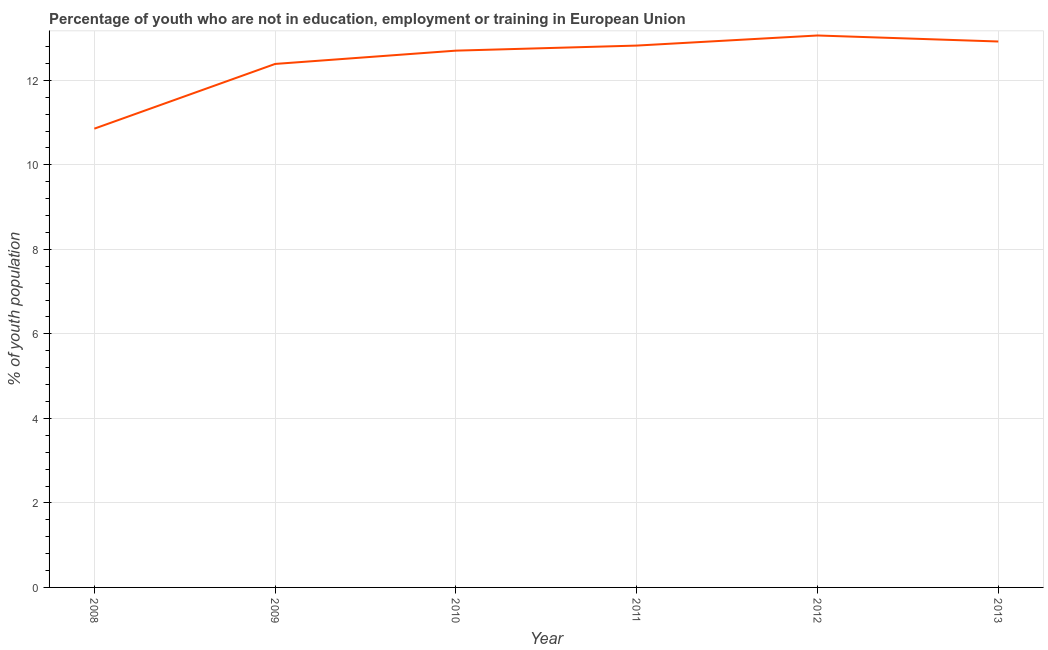What is the unemployed youth population in 2008?
Your response must be concise. 10.86. Across all years, what is the maximum unemployed youth population?
Your response must be concise. 13.06. Across all years, what is the minimum unemployed youth population?
Ensure brevity in your answer.  10.86. In which year was the unemployed youth population minimum?
Keep it short and to the point. 2008. What is the sum of the unemployed youth population?
Your answer should be very brief. 74.74. What is the difference between the unemployed youth population in 2011 and 2012?
Keep it short and to the point. -0.24. What is the average unemployed youth population per year?
Offer a terse response. 12.46. What is the median unemployed youth population?
Make the answer very short. 12.76. What is the ratio of the unemployed youth population in 2008 to that in 2011?
Your response must be concise. 0.85. Is the unemployed youth population in 2008 less than that in 2010?
Give a very brief answer. Yes. What is the difference between the highest and the second highest unemployed youth population?
Offer a terse response. 0.14. What is the difference between the highest and the lowest unemployed youth population?
Give a very brief answer. 2.2. In how many years, is the unemployed youth population greater than the average unemployed youth population taken over all years?
Provide a short and direct response. 4. Does the unemployed youth population monotonically increase over the years?
Keep it short and to the point. No. What is the difference between two consecutive major ticks on the Y-axis?
Your response must be concise. 2. Are the values on the major ticks of Y-axis written in scientific E-notation?
Your answer should be very brief. No. Does the graph contain any zero values?
Offer a terse response. No. Does the graph contain grids?
Offer a very short reply. Yes. What is the title of the graph?
Offer a very short reply. Percentage of youth who are not in education, employment or training in European Union. What is the label or title of the X-axis?
Keep it short and to the point. Year. What is the label or title of the Y-axis?
Keep it short and to the point. % of youth population. What is the % of youth population of 2008?
Provide a short and direct response. 10.86. What is the % of youth population in 2009?
Your response must be concise. 12.39. What is the % of youth population of 2010?
Provide a succinct answer. 12.7. What is the % of youth population of 2011?
Provide a succinct answer. 12.82. What is the % of youth population of 2012?
Provide a succinct answer. 13.06. What is the % of youth population in 2013?
Your response must be concise. 12.92. What is the difference between the % of youth population in 2008 and 2009?
Give a very brief answer. -1.53. What is the difference between the % of youth population in 2008 and 2010?
Provide a succinct answer. -1.85. What is the difference between the % of youth population in 2008 and 2011?
Ensure brevity in your answer.  -1.97. What is the difference between the % of youth population in 2008 and 2012?
Your answer should be very brief. -2.2. What is the difference between the % of youth population in 2008 and 2013?
Your answer should be compact. -2.06. What is the difference between the % of youth population in 2009 and 2010?
Offer a terse response. -0.31. What is the difference between the % of youth population in 2009 and 2011?
Make the answer very short. -0.43. What is the difference between the % of youth population in 2009 and 2012?
Your answer should be very brief. -0.67. What is the difference between the % of youth population in 2009 and 2013?
Offer a very short reply. -0.53. What is the difference between the % of youth population in 2010 and 2011?
Offer a very short reply. -0.12. What is the difference between the % of youth population in 2010 and 2012?
Offer a very short reply. -0.36. What is the difference between the % of youth population in 2010 and 2013?
Offer a very short reply. -0.22. What is the difference between the % of youth population in 2011 and 2012?
Ensure brevity in your answer.  -0.24. What is the difference between the % of youth population in 2011 and 2013?
Ensure brevity in your answer.  -0.1. What is the difference between the % of youth population in 2012 and 2013?
Your response must be concise. 0.14. What is the ratio of the % of youth population in 2008 to that in 2009?
Your response must be concise. 0.88. What is the ratio of the % of youth population in 2008 to that in 2010?
Offer a very short reply. 0.85. What is the ratio of the % of youth population in 2008 to that in 2011?
Your response must be concise. 0.85. What is the ratio of the % of youth population in 2008 to that in 2012?
Give a very brief answer. 0.83. What is the ratio of the % of youth population in 2008 to that in 2013?
Provide a succinct answer. 0.84. What is the ratio of the % of youth population in 2009 to that in 2010?
Provide a succinct answer. 0.97. What is the ratio of the % of youth population in 2009 to that in 2011?
Offer a terse response. 0.97. What is the ratio of the % of youth population in 2009 to that in 2012?
Offer a terse response. 0.95. What is the ratio of the % of youth population in 2009 to that in 2013?
Give a very brief answer. 0.96. What is the ratio of the % of youth population in 2010 to that in 2012?
Your answer should be very brief. 0.97. What is the ratio of the % of youth population in 2010 to that in 2013?
Give a very brief answer. 0.98. What is the ratio of the % of youth population in 2011 to that in 2012?
Your response must be concise. 0.98. 